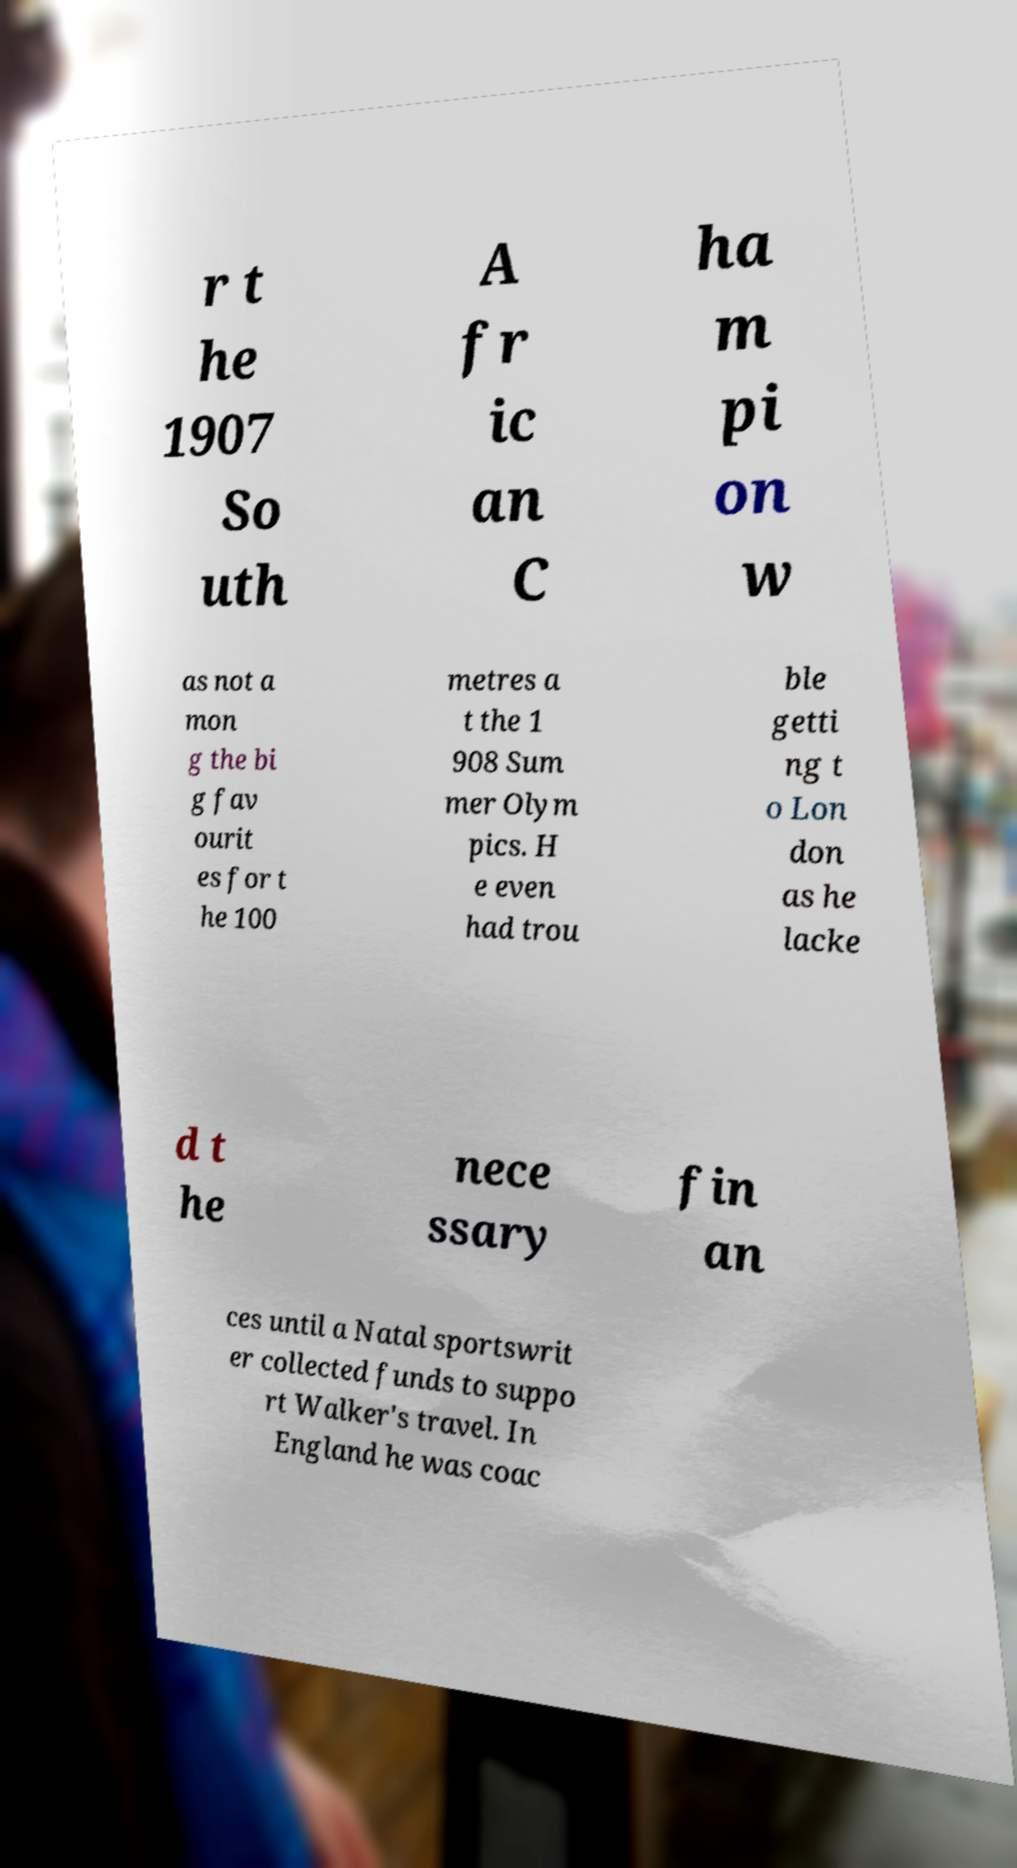Can you accurately transcribe the text from the provided image for me? r t he 1907 So uth A fr ic an C ha m pi on w as not a mon g the bi g fav ourit es for t he 100 metres a t the 1 908 Sum mer Olym pics. H e even had trou ble getti ng t o Lon don as he lacke d t he nece ssary fin an ces until a Natal sportswrit er collected funds to suppo rt Walker's travel. In England he was coac 